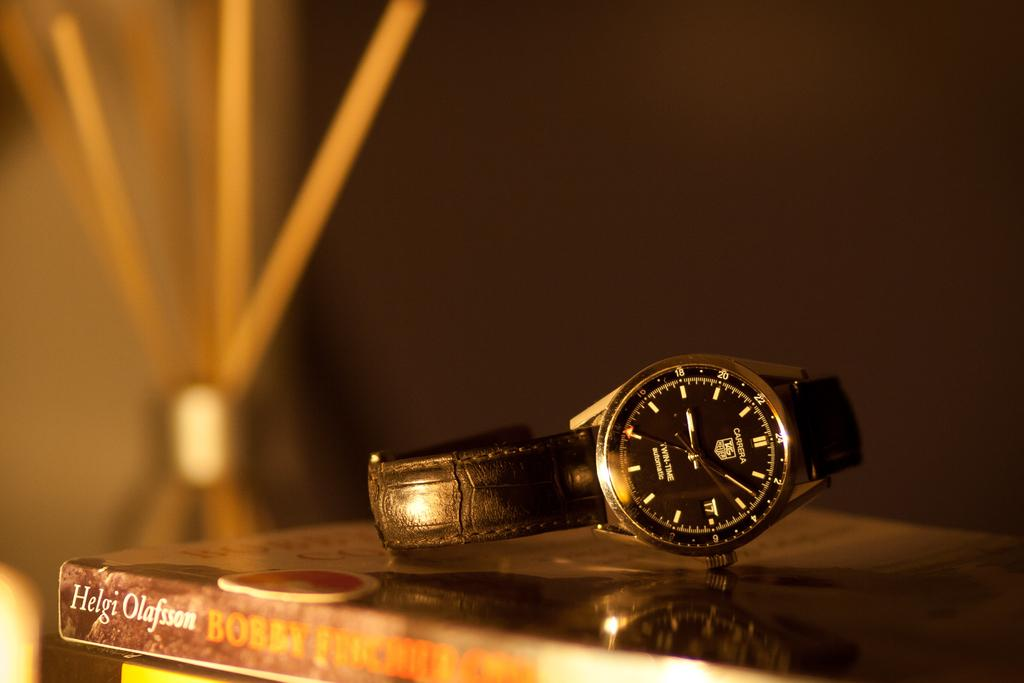<image>
Render a clear and concise summary of the photo. A watch sits on a book by Helgi Olafsson 